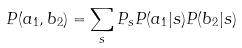<formula> <loc_0><loc_0><loc_500><loc_500>P ( a _ { 1 } , b _ { 2 } ) = \sum _ { s } P _ { s } P ( a _ { 1 } | s ) P ( b _ { 2 } | s )</formula> 